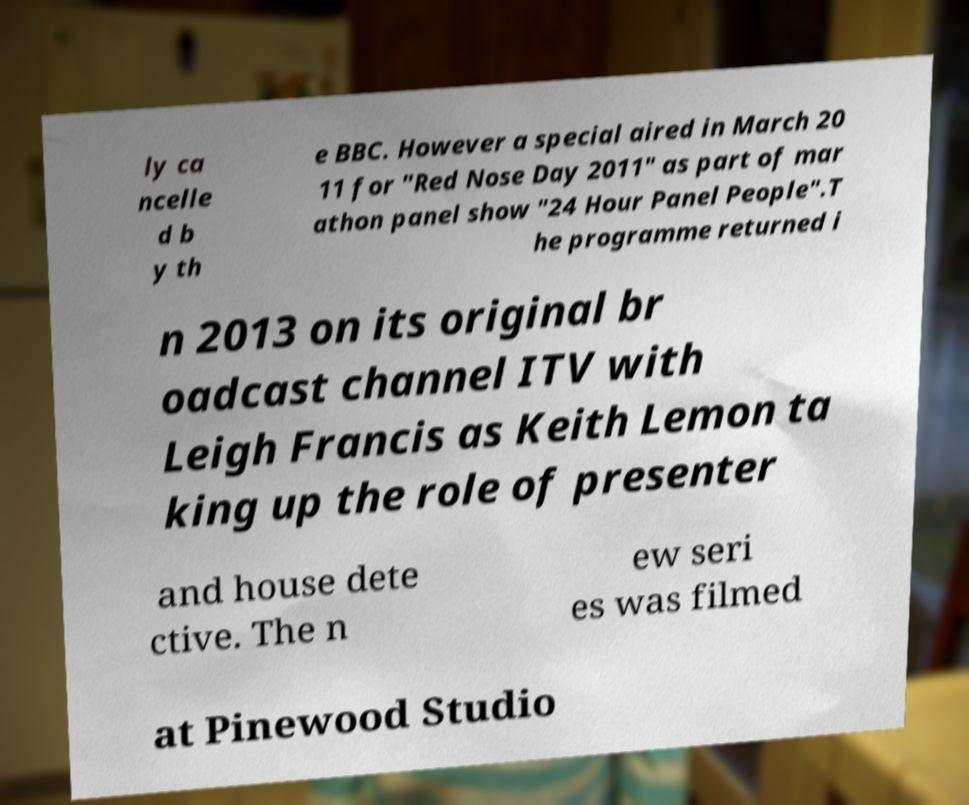For documentation purposes, I need the text within this image transcribed. Could you provide that? ly ca ncelle d b y th e BBC. However a special aired in March 20 11 for "Red Nose Day 2011" as part of mar athon panel show "24 Hour Panel People".T he programme returned i n 2013 on its original br oadcast channel ITV with Leigh Francis as Keith Lemon ta king up the role of presenter and house dete ctive. The n ew seri es was filmed at Pinewood Studio 